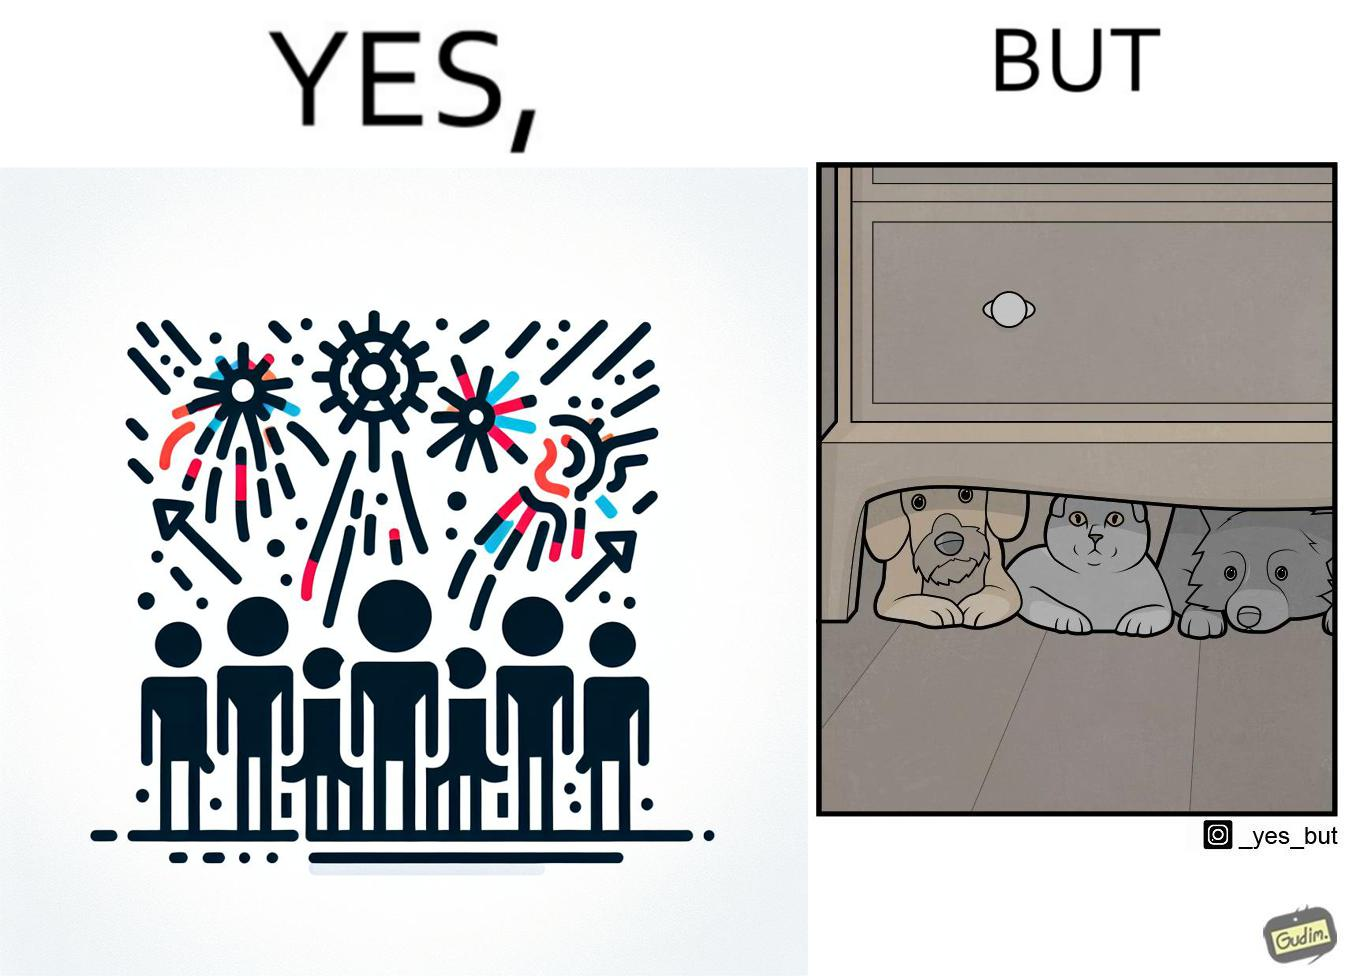What does this image depict? The image is satirical because while firecrackers in the sky look pretty, not everyone likes them. Animals are very scared of the firecrackers. 